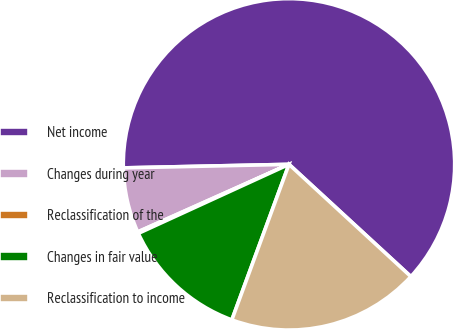Convert chart. <chart><loc_0><loc_0><loc_500><loc_500><pie_chart><fcel>Net income<fcel>Changes during year<fcel>Reclassification of the<fcel>Changes in fair value<fcel>Reclassification to income<nl><fcel>62.19%<fcel>6.35%<fcel>0.15%<fcel>12.56%<fcel>18.76%<nl></chart> 